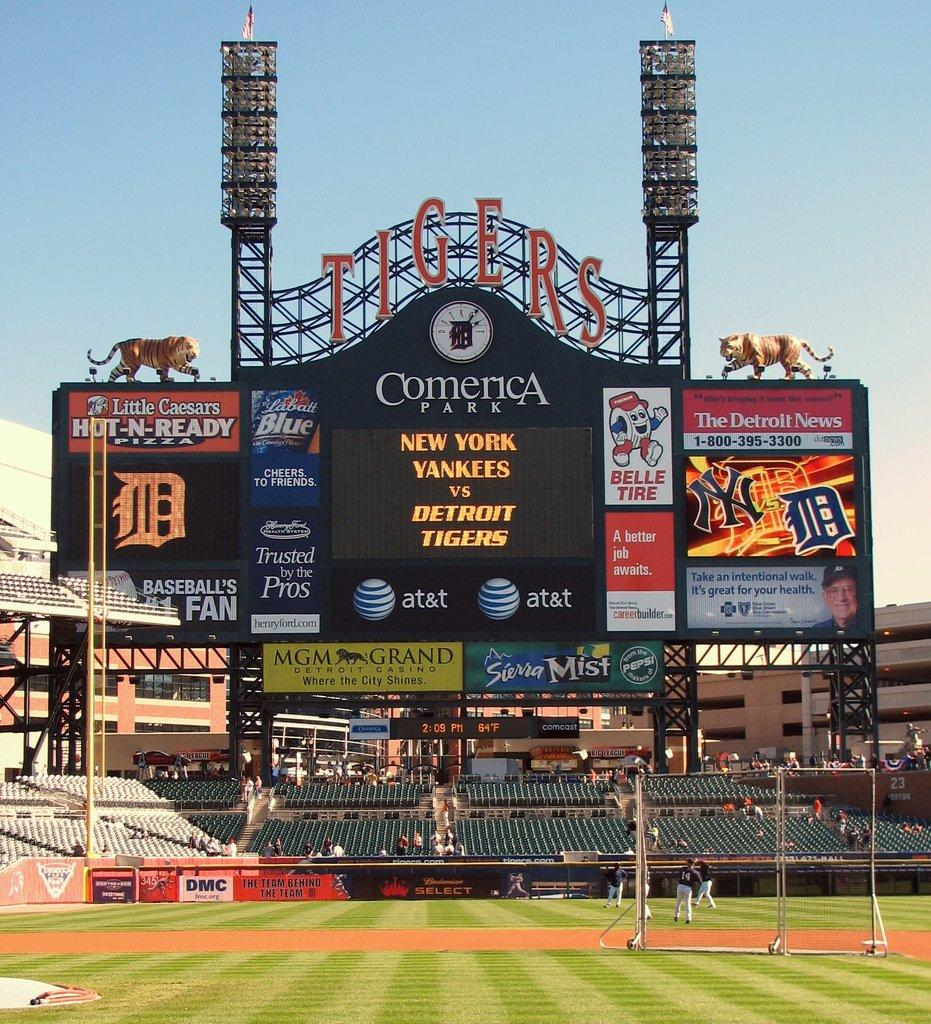Provide a one-sentence caption for the provided image. The teams playing baseball are the Yankees and Tigers. 